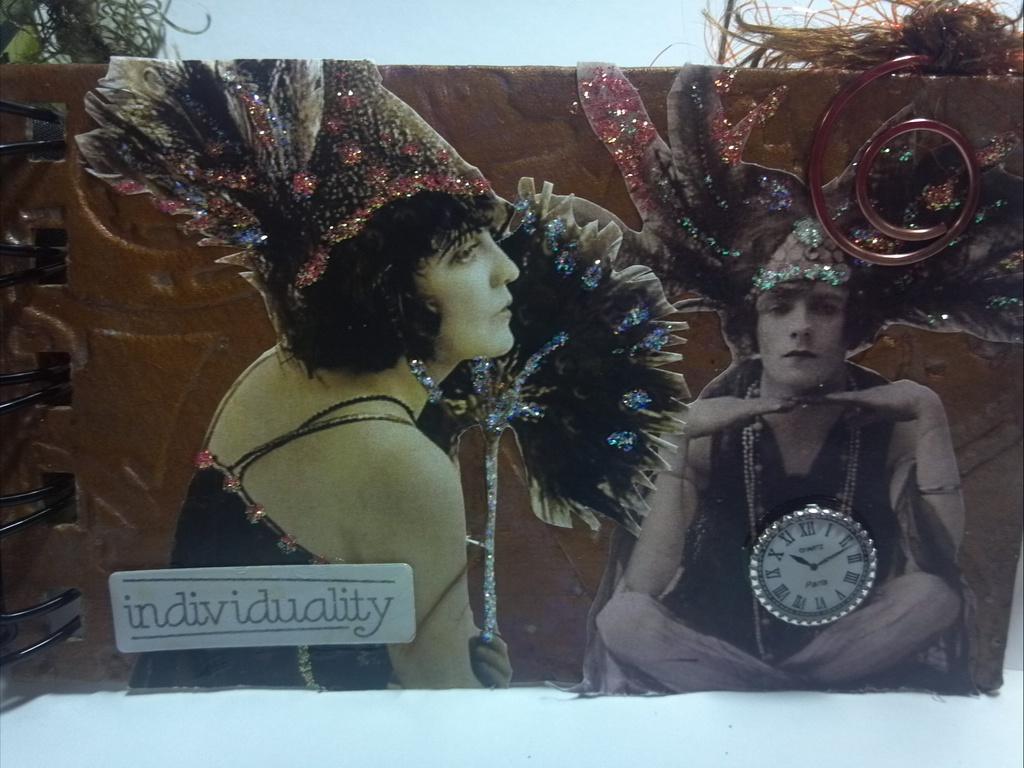What word is that?
Offer a very short reply. Individuality. What is written in the bottom left corner?
Provide a short and direct response. Individuality. 